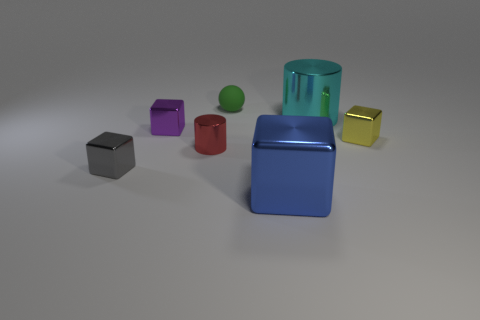There is a cylinder on the right side of the green matte sphere; how big is it?
Keep it short and to the point. Large. There is a metal cylinder that is the same size as the matte thing; what color is it?
Offer a very short reply. Red. Is the number of tiny yellow metallic blocks on the left side of the large metallic cylinder less than the number of tiny purple cubes that are on the left side of the small cylinder?
Offer a terse response. Yes. What material is the thing that is on the right side of the tiny red cylinder and left of the large metal block?
Provide a succinct answer. Rubber. There is a tiny red thing; is it the same shape as the big thing behind the yellow metallic thing?
Offer a terse response. Yes. What number of other things are there of the same size as the blue block?
Keep it short and to the point. 1. Are there more large shiny cylinders than small brown cylinders?
Provide a succinct answer. Yes. How many tiny metallic things are both on the left side of the yellow metallic thing and behind the red cylinder?
Your answer should be very brief. 1. There is a small metal object that is to the right of the green sphere behind the shiny cylinder on the left side of the tiny rubber sphere; what shape is it?
Keep it short and to the point. Cube. Is there any other thing that is the same shape as the rubber thing?
Ensure brevity in your answer.  No. 